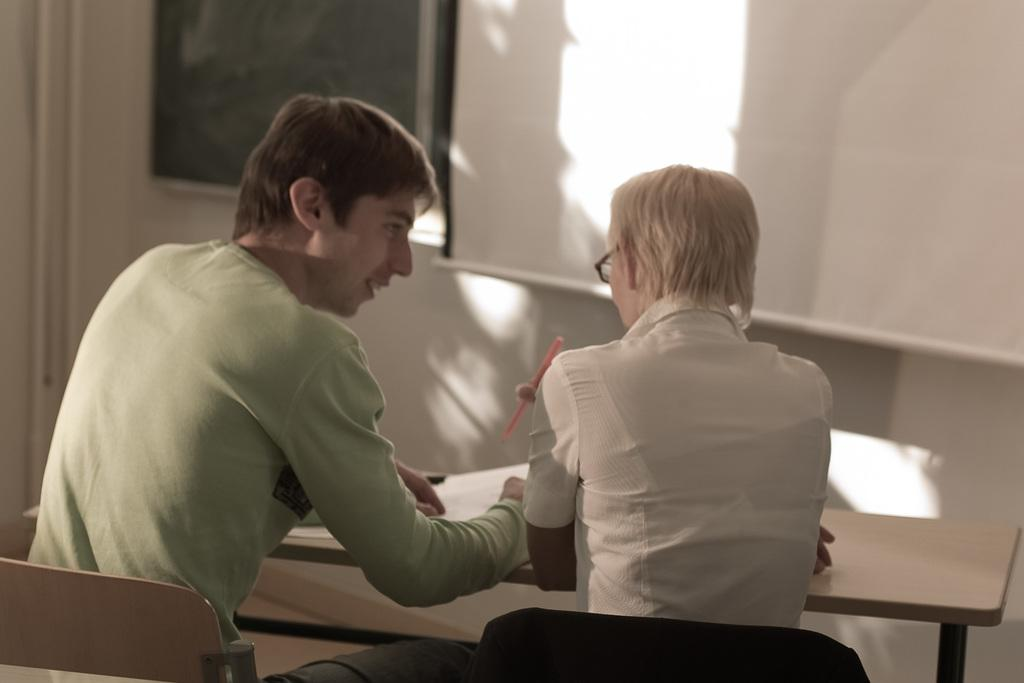How many people are the people are present in the image? There are two people in the image, a man and a woman. What are the man and woman doing in the image? Both the man and woman are sitting on chairs in the image. What is in front of the chairs? There is a desk in front of the chairs. What can be seen in the background of the image? There is a whiteboard in the background. What type of setting is suggested by the presence of chairs, a desk, and a whiteboard? The setting appears to be a classroom. How many baskets are visible on the desk in the image? There are no baskets visible on the desk in the image. What type of measurement can be seen on the whiteboard in the image? There is no measurement visible on the whiteboard in the image. 